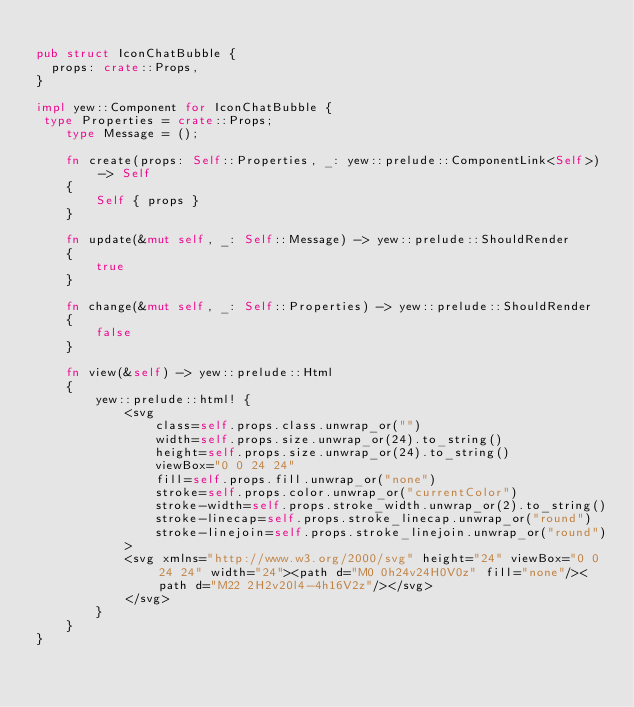<code> <loc_0><loc_0><loc_500><loc_500><_Rust_>
pub struct IconChatBubble {
  props: crate::Props,
}

impl yew::Component for IconChatBubble {
 type Properties = crate::Props;
    type Message = ();

    fn create(props: Self::Properties, _: yew::prelude::ComponentLink<Self>) -> Self
    {
        Self { props }
    }

    fn update(&mut self, _: Self::Message) -> yew::prelude::ShouldRender
    {
        true
    }

    fn change(&mut self, _: Self::Properties) -> yew::prelude::ShouldRender
    {
        false
    }

    fn view(&self) -> yew::prelude::Html
    {
        yew::prelude::html! {
            <svg
                class=self.props.class.unwrap_or("")
                width=self.props.size.unwrap_or(24).to_string()
                height=self.props.size.unwrap_or(24).to_string()
                viewBox="0 0 24 24"
                fill=self.props.fill.unwrap_or("none")
                stroke=self.props.color.unwrap_or("currentColor")
                stroke-width=self.props.stroke_width.unwrap_or(2).to_string()
                stroke-linecap=self.props.stroke_linecap.unwrap_or("round")
                stroke-linejoin=self.props.stroke_linejoin.unwrap_or("round")
            >
            <svg xmlns="http://www.w3.org/2000/svg" height="24" viewBox="0 0 24 24" width="24"><path d="M0 0h24v24H0V0z" fill="none"/><path d="M22 2H2v20l4-4h16V2z"/></svg>
            </svg>
        }
    }
}


</code> 